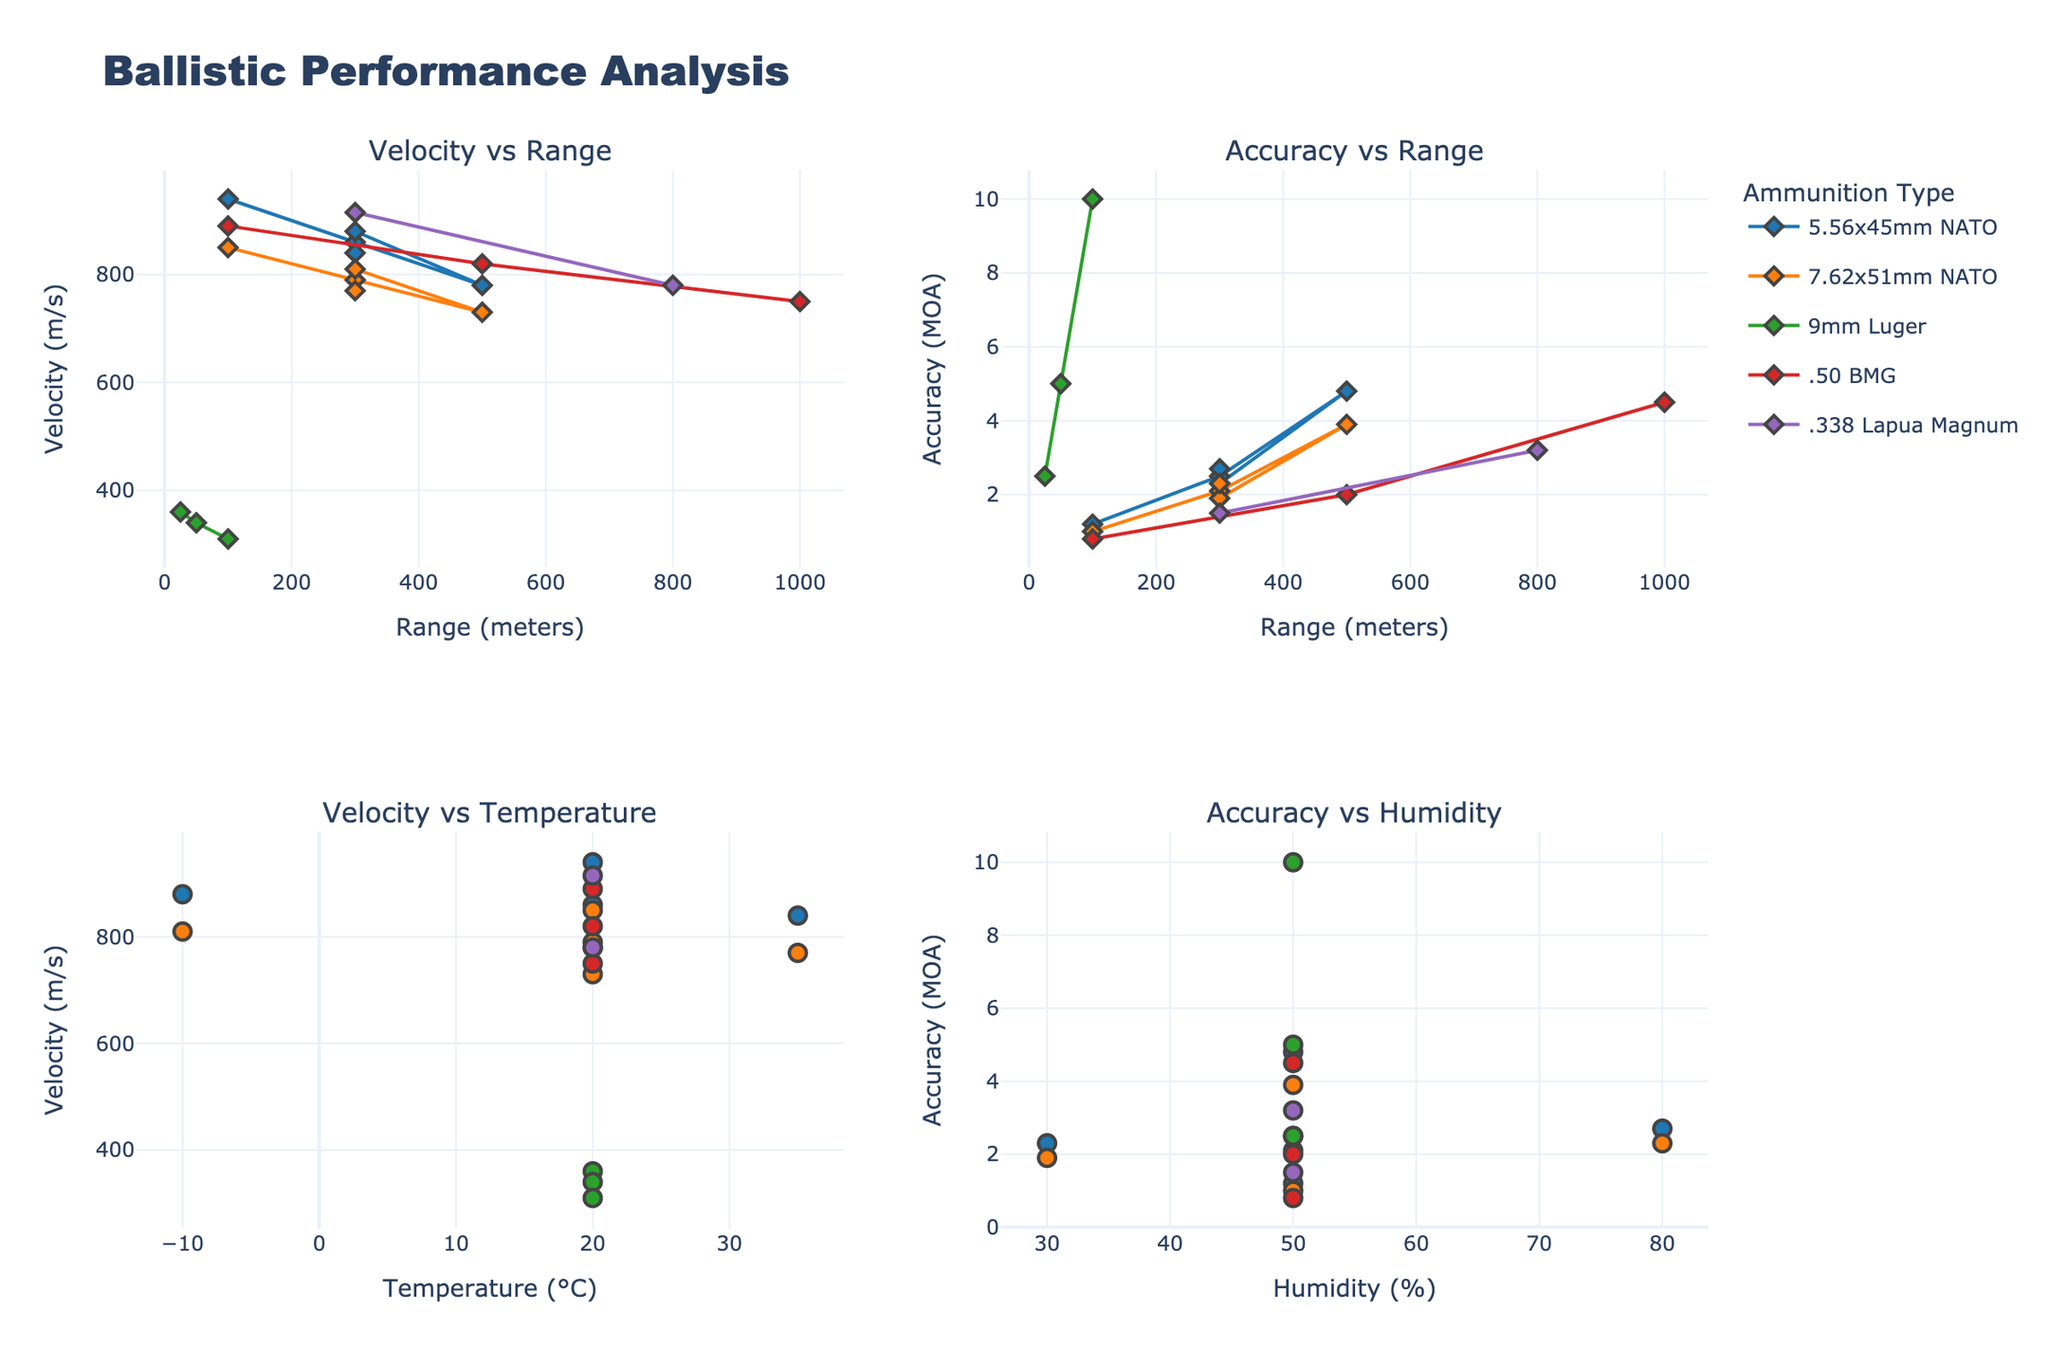What's the title of the figure? The title of the figure is displayed at the top center of the image. It provides an overall summary of what the chart is about.
Answer: Ballistic Performance Analysis How many subplots are there in the figure? The figure is organized into a grid layout with multiple smaller plots within it. We can see four distinctive sections.
Answer: Four Which ammunition type has the highest velocity at 100 meters? By examining the subplot "Velocity vs Range", identify the velocity at the 100 meters range and compare all ammunition types visible in this range.
Answer: 5.56x45mm NATO How does the velocity of 7.62x51mm NATO change from 100 meters to 500 meters? In the subplot "Velocity vs Range", look at the data points for 7.62x51mm NATO at 100 meters and 500 meters and observe the change.
Answer: Decreases Which ammunition type shows the highest accuracy at 300 meters? Observing the "Accuracy vs Range" subplot, look at the data points at the 300 meters mark and compare the accuracy for each type of ammunition.
Answer: 7.62x51mm NATO What is the temperature range covered in the "Velocity vs Temperature" subplot? The temperature range can be determined by looking at the x-axis of the subplot titled "Velocity vs Temperature".
Answer: -10 to 35°C Compare the accuracies of 9mm Luger at 25 meters and 100 meters. Navigate to the "Accuracy vs Range" subplot, locate the points for 9mm Luger at 25 meters and 100 meters, and compare the circle symbol values visually.
Answer: 2.5 at 25m, 10.0 at 100m Which ammunition type has the most significant drop in velocity as the range increases from 100 meters to 1000 meters? Examine the "Velocity vs Range" subplot and observe the trend line slopes for each ammunition type between these ranges. The one with the steepest negative slope shows the most significant drop.
Answer: .50 BMG How does the accuracy of 5.56x45mm NATO change with humidity? Refer to the "Accuracy vs Humidity" subplot and observe how the data points for 5.56x45mm NATO spread along the humidity percentage range.
Answer: Fluctuates What is the velocity of .338 Lapua Magnum at 300 meters? Locate the data points for .338 Lapua Magnum on the "Velocity vs Range" subplot near the 300 meters mark and read the value on the y-axis.
Answer: 915 m/s 